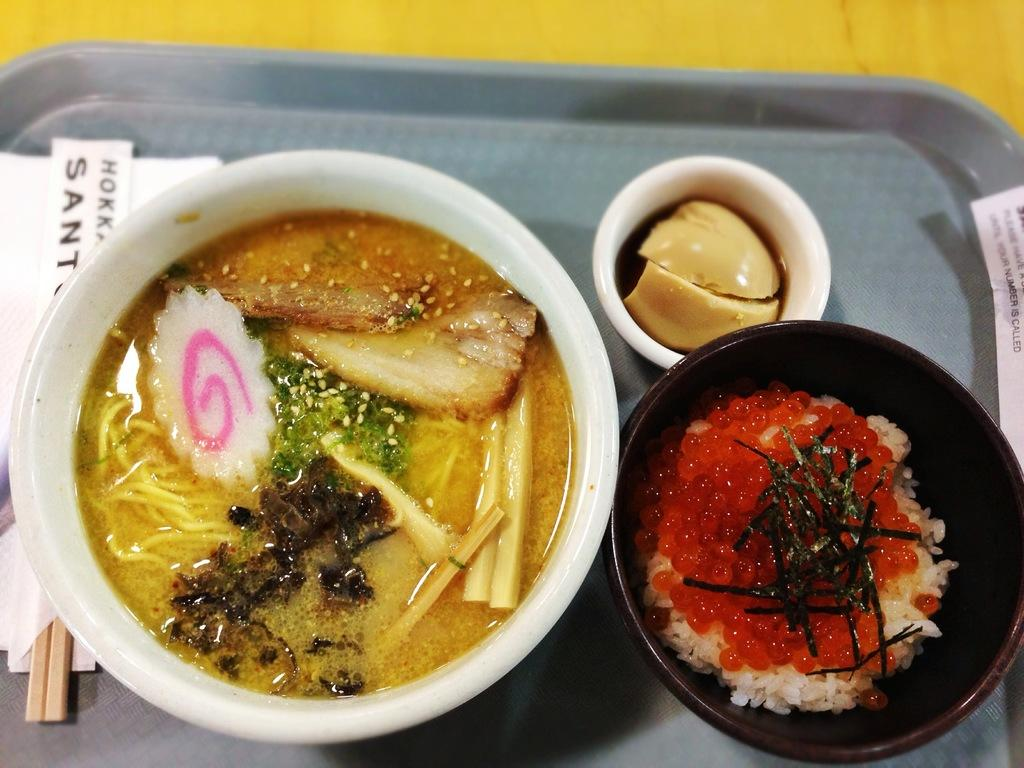What types of food can be seen in the image? There are three different food items in the image. How are the food items arranged in the image? Each food item is served in a separate bowl, and the bowls are placed on a tray. What utensils are present in the image? There are two chopsticks beside the bowls. Can you tell me how many lettuce leaves are in the image? There is no lettuce present in the image; it only contains three different food items served in separate bowls. Is there a farmer in the image tending to the food? There is no farmer present in the image; it only shows the food items arranged on a tray with chopsticks beside them. 